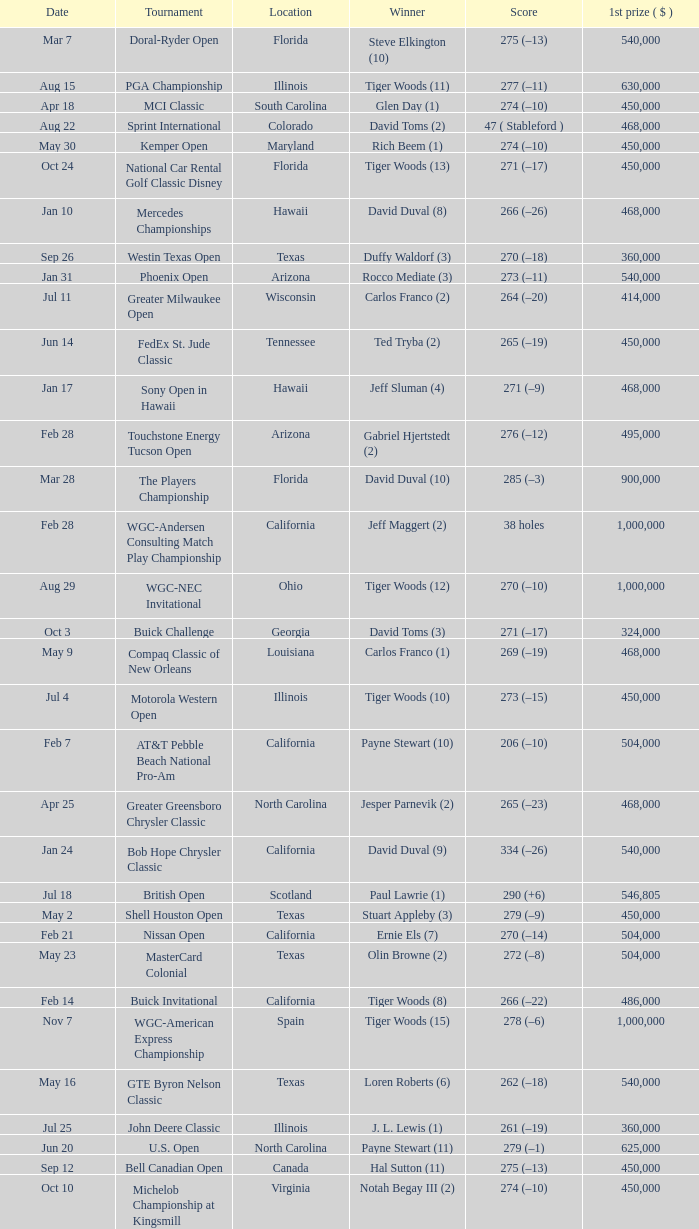What is the date of the Greater Greensboro Chrysler Classic? Apr 25. 